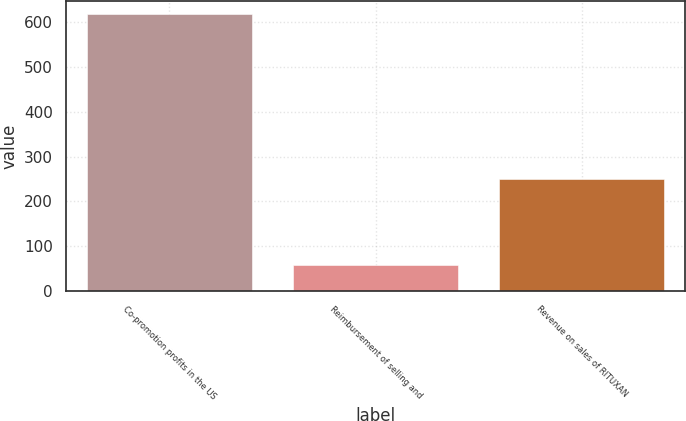Convert chart. <chart><loc_0><loc_0><loc_500><loc_500><bar_chart><fcel>Co-promotion profits in the US<fcel>Reimbursement of selling and<fcel>Revenue on sales of RITUXAN<nl><fcel>616.8<fcel>58.5<fcel>250.8<nl></chart> 